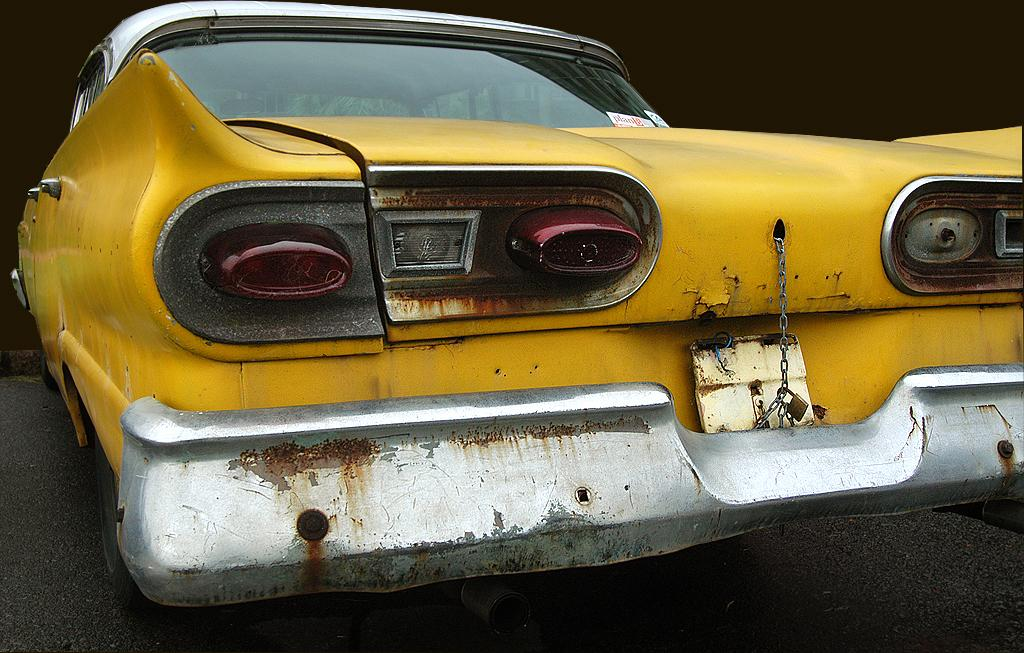What is the main subject of the image? The main subject of the image is a car. What colors are used for the car in the image? The car is yellow and white in color. What can be seen in the background of the image? The background of the image is dark. What type of event is taking place in the image involving a goat and brothers? There is no event, goat, or brothers present in the image; it features a yellow and white car. 